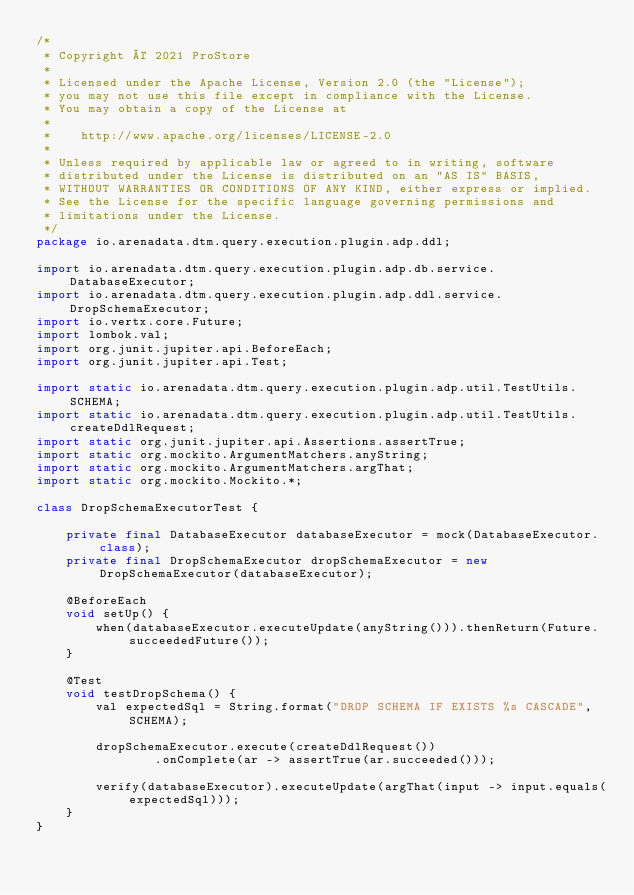<code> <loc_0><loc_0><loc_500><loc_500><_Java_>/*
 * Copyright © 2021 ProStore
 *
 * Licensed under the Apache License, Version 2.0 (the "License");
 * you may not use this file except in compliance with the License.
 * You may obtain a copy of the License at
 *
 *    http://www.apache.org/licenses/LICENSE-2.0
 *
 * Unless required by applicable law or agreed to in writing, software
 * distributed under the License is distributed on an "AS IS" BASIS,
 * WITHOUT WARRANTIES OR CONDITIONS OF ANY KIND, either express or implied.
 * See the License for the specific language governing permissions and
 * limitations under the License.
 */
package io.arenadata.dtm.query.execution.plugin.adp.ddl;

import io.arenadata.dtm.query.execution.plugin.adp.db.service.DatabaseExecutor;
import io.arenadata.dtm.query.execution.plugin.adp.ddl.service.DropSchemaExecutor;
import io.vertx.core.Future;
import lombok.val;
import org.junit.jupiter.api.BeforeEach;
import org.junit.jupiter.api.Test;

import static io.arenadata.dtm.query.execution.plugin.adp.util.TestUtils.SCHEMA;
import static io.arenadata.dtm.query.execution.plugin.adp.util.TestUtils.createDdlRequest;
import static org.junit.jupiter.api.Assertions.assertTrue;
import static org.mockito.ArgumentMatchers.anyString;
import static org.mockito.ArgumentMatchers.argThat;
import static org.mockito.Mockito.*;

class DropSchemaExecutorTest {

    private final DatabaseExecutor databaseExecutor = mock(DatabaseExecutor.class);
    private final DropSchemaExecutor dropSchemaExecutor = new DropSchemaExecutor(databaseExecutor);

    @BeforeEach
    void setUp() {
        when(databaseExecutor.executeUpdate(anyString())).thenReturn(Future.succeededFuture());
    }

    @Test
    void testDropSchema() {
        val expectedSql = String.format("DROP SCHEMA IF EXISTS %s CASCADE", SCHEMA);

        dropSchemaExecutor.execute(createDdlRequest())
                .onComplete(ar -> assertTrue(ar.succeeded()));

        verify(databaseExecutor).executeUpdate(argThat(input -> input.equals(expectedSql)));
    }
}
</code> 